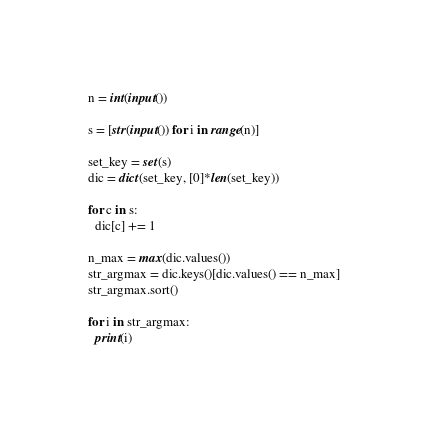<code> <loc_0><loc_0><loc_500><loc_500><_Python_>n = int(input())
 
s = [str(input()) for i in range(n)]

set_key = set(s)
dic = dict(set_key, [0]*len(set_key))

for c in s:
  dic[c] += 1
  
n_max = max(dic.values())
str_argmax = dic.keys()[dic.values() == n_max]
str_argmax.sort()

for i in str_argmax:
  print(i)</code> 